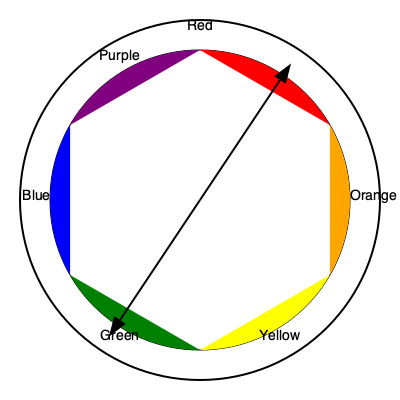In "Marriage Story," the color palette predominantly features warm oranges and cool blues. Based on the color wheel provided, what type of color scheme does this represent, and how does it contribute to the film's emotional narrative? 1. Analyze the color wheel:
   - Observe that orange and blue are located on opposite sides of the color wheel.
   - Colors opposite each other on the color wheel are called complementary colors.

2. Identify the color scheme:
   - The use of orange and blue as dominant colors in "Marriage Story" represents a complementary color scheme.

3. Understand the psychological effects of these colors:
   - Orange is associated with warmth, energy, and enthusiasm.
   - Blue is associated with calmness, stability, and melancholy.

4. Analyze the emotional narrative:
   - The warm oranges often represent the characters' passionate moments and the warmth of their past relationship.
   - The cool blues symbolize the emotional distance and sadness that develops as their marriage deteriorates.

5. Consider the visual contrast:
   - Complementary colors create a strong visual contrast when used together.
   - This contrast mirrors the emotional conflict and tension between the characters.

6. Reflect on the overall impact:
   - The complementary color scheme visually represents the characters' conflicting emotions and the complex nature of their relationship.
   - It enhances the viewer's emotional experience by subtly reinforcing the narrative's themes of love, conflict, and separation.
Answer: Complementary color scheme; visually represents conflicting emotions and relationship complexity 